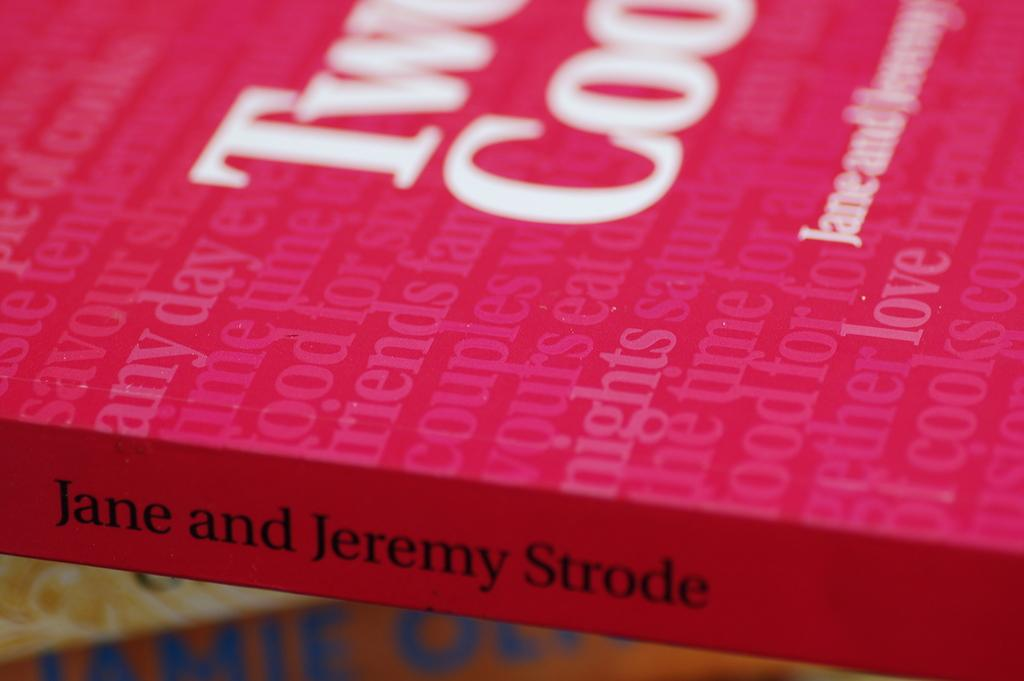<image>
Describe the image concisely. Jane and Jeremy Strode wrote this book together. 